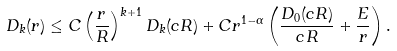<formula> <loc_0><loc_0><loc_500><loc_500>D _ { k } ( r ) \leq C \left ( \frac { r } { R } \right ) ^ { k + 1 } D _ { k } ( c R ) + C r ^ { 1 - \alpha } \left ( \frac { D _ { 0 } ( c R ) } { c R } + \frac { E } { r } \right ) .</formula> 